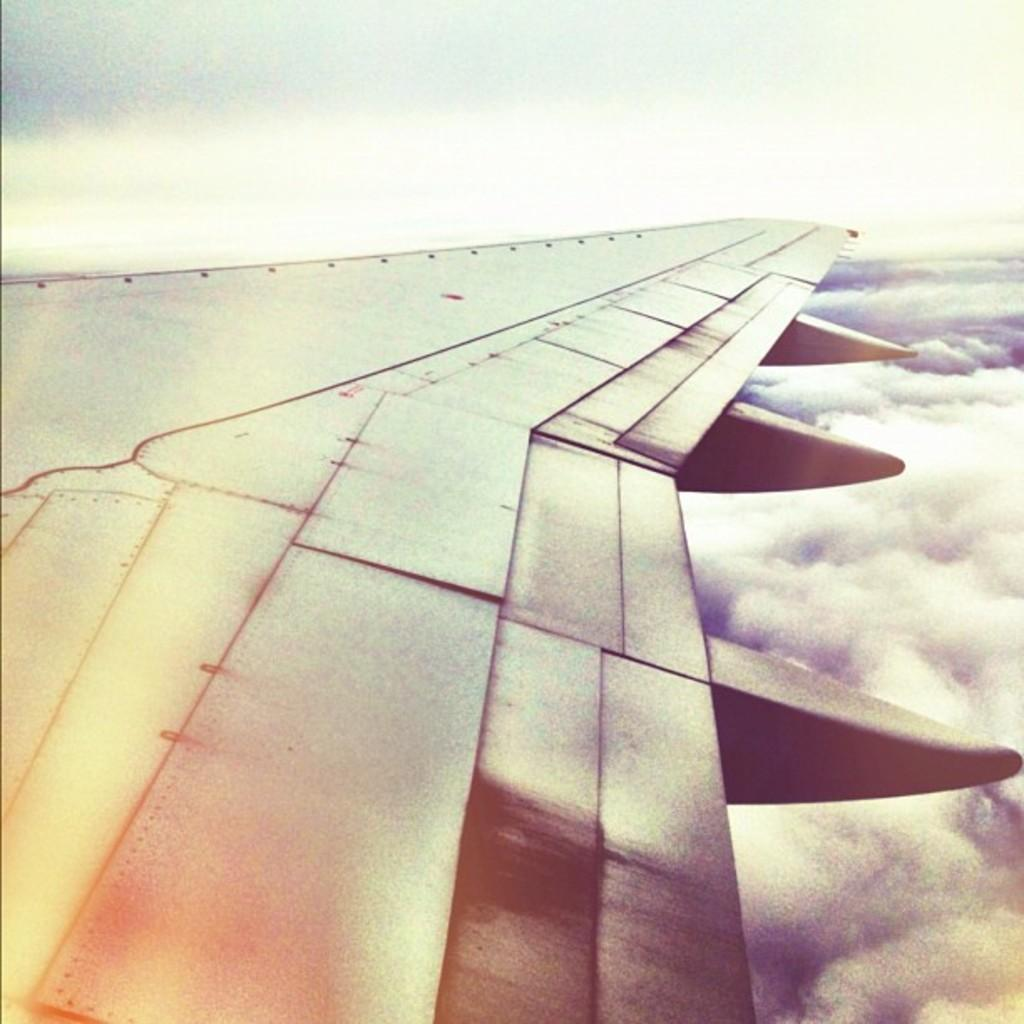What is the main subject of the image? The main subject of the image is an airplane. Where is the airplane located in the image? The airplane is in the front of the image. What can be seen in the background of the image? The sky and clouds are visible in the background of the image. What type of cake is being served by the scarecrow in the image? There is no cake or scarecrow present in the image; it features an airplane in the front with a sky and clouds in the background. 